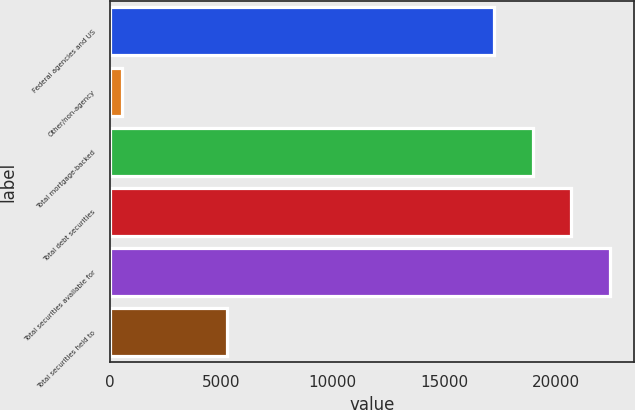<chart> <loc_0><loc_0><loc_500><loc_500><bar_chart><fcel>Federal agencies and US<fcel>Other/non-agency<fcel>Total mortgage-backed<fcel>Total debt securities<fcel>Total securities available for<fcel>Total securities held to<nl><fcel>17234<fcel>555<fcel>18961.6<fcel>20689.2<fcel>22416.8<fcel>5258<nl></chart> 